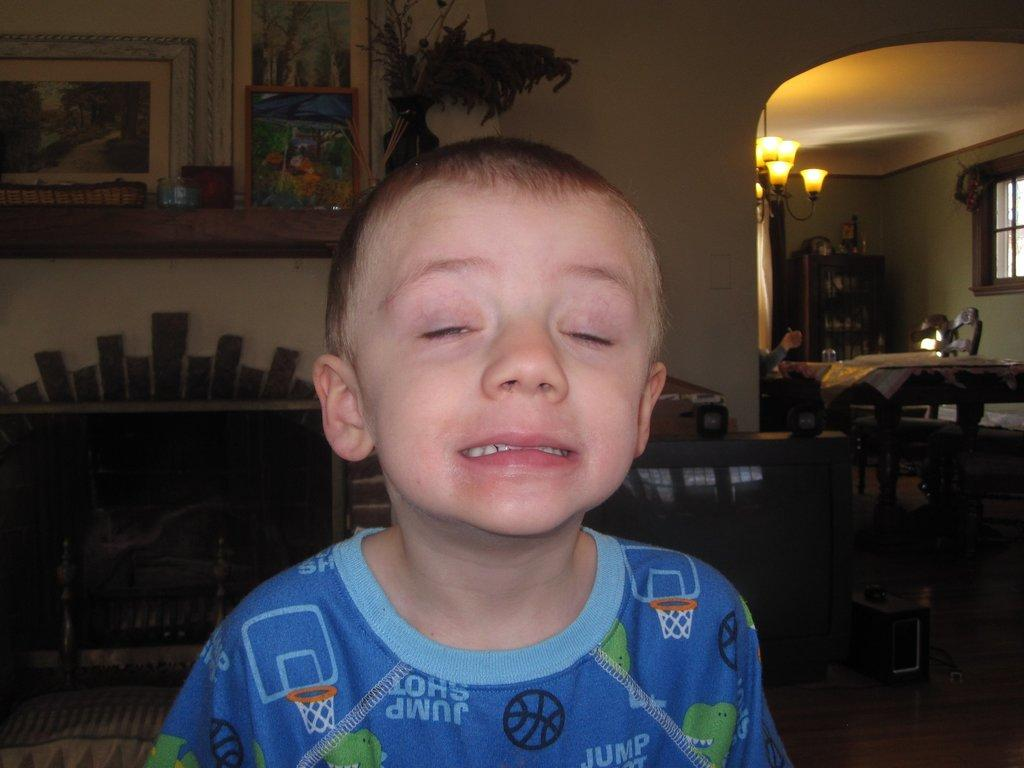What is the main subject of the image? There is a boy standing in the image. What can be seen in the background of the image? There is a fireplace in the background. What is present on the wall in the image? Photo frames are present on the wall. What type of vegetation is near the wall? Plants are near the wall. What is fixed to the wall in the image? A chandelier is fixed to the wall. What piece of furniture is in the image? There is a table in the image. What architectural feature is visible in the image? There is a window in the image. How much money is the boy holding in the image? The image does not show the boy holding any money, so it cannot be determined from the image. 